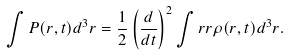<formula> <loc_0><loc_0><loc_500><loc_500>\int { P } ( { r } , t ) d ^ { 3 } { r } = \frac { 1 } { 2 } \left ( \frac { d } { d t } \right ) ^ { 2 } \int { r } { r } \rho ( { r } , t ) d ^ { 3 } { r } .</formula> 